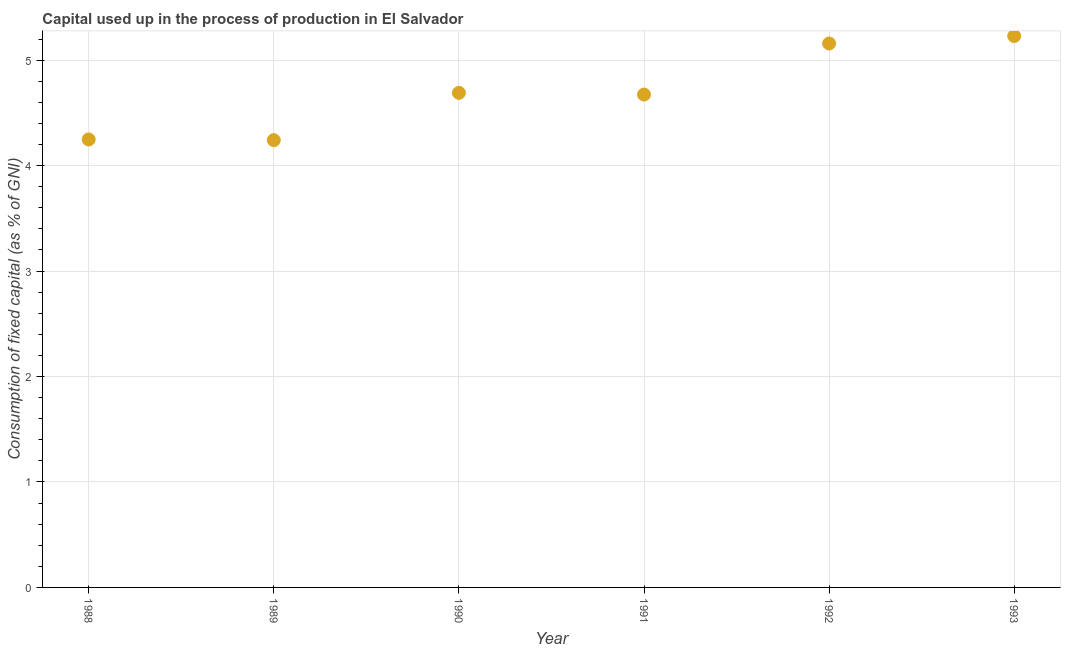What is the consumption of fixed capital in 1993?
Give a very brief answer. 5.23. Across all years, what is the maximum consumption of fixed capital?
Make the answer very short. 5.23. Across all years, what is the minimum consumption of fixed capital?
Your response must be concise. 4.24. In which year was the consumption of fixed capital minimum?
Give a very brief answer. 1989. What is the sum of the consumption of fixed capital?
Your answer should be compact. 28.24. What is the difference between the consumption of fixed capital in 1990 and 1992?
Offer a terse response. -0.47. What is the average consumption of fixed capital per year?
Make the answer very short. 4.71. What is the median consumption of fixed capital?
Provide a short and direct response. 4.68. In how many years, is the consumption of fixed capital greater than 2.4 %?
Keep it short and to the point. 6. Do a majority of the years between 1992 and 1991 (inclusive) have consumption of fixed capital greater than 2.8 %?
Offer a very short reply. No. What is the ratio of the consumption of fixed capital in 1991 to that in 1992?
Ensure brevity in your answer.  0.91. Is the difference between the consumption of fixed capital in 1989 and 1992 greater than the difference between any two years?
Keep it short and to the point. No. What is the difference between the highest and the second highest consumption of fixed capital?
Offer a very short reply. 0.07. Is the sum of the consumption of fixed capital in 1990 and 1991 greater than the maximum consumption of fixed capital across all years?
Your answer should be compact. Yes. What is the difference between the highest and the lowest consumption of fixed capital?
Offer a very short reply. 0.99. In how many years, is the consumption of fixed capital greater than the average consumption of fixed capital taken over all years?
Provide a short and direct response. 2. Does the consumption of fixed capital monotonically increase over the years?
Give a very brief answer. No. How many dotlines are there?
Provide a short and direct response. 1. Are the values on the major ticks of Y-axis written in scientific E-notation?
Your answer should be very brief. No. What is the title of the graph?
Ensure brevity in your answer.  Capital used up in the process of production in El Salvador. What is the label or title of the Y-axis?
Make the answer very short. Consumption of fixed capital (as % of GNI). What is the Consumption of fixed capital (as % of GNI) in 1988?
Give a very brief answer. 4.25. What is the Consumption of fixed capital (as % of GNI) in 1989?
Your answer should be compact. 4.24. What is the Consumption of fixed capital (as % of GNI) in 1990?
Offer a very short reply. 4.69. What is the Consumption of fixed capital (as % of GNI) in 1991?
Make the answer very short. 4.67. What is the Consumption of fixed capital (as % of GNI) in 1992?
Keep it short and to the point. 5.16. What is the Consumption of fixed capital (as % of GNI) in 1993?
Keep it short and to the point. 5.23. What is the difference between the Consumption of fixed capital (as % of GNI) in 1988 and 1989?
Offer a very short reply. 0.01. What is the difference between the Consumption of fixed capital (as % of GNI) in 1988 and 1990?
Provide a succinct answer. -0.44. What is the difference between the Consumption of fixed capital (as % of GNI) in 1988 and 1991?
Ensure brevity in your answer.  -0.43. What is the difference between the Consumption of fixed capital (as % of GNI) in 1988 and 1992?
Give a very brief answer. -0.91. What is the difference between the Consumption of fixed capital (as % of GNI) in 1988 and 1993?
Ensure brevity in your answer.  -0.98. What is the difference between the Consumption of fixed capital (as % of GNI) in 1989 and 1990?
Keep it short and to the point. -0.45. What is the difference between the Consumption of fixed capital (as % of GNI) in 1989 and 1991?
Keep it short and to the point. -0.43. What is the difference between the Consumption of fixed capital (as % of GNI) in 1989 and 1992?
Offer a terse response. -0.92. What is the difference between the Consumption of fixed capital (as % of GNI) in 1989 and 1993?
Offer a very short reply. -0.99. What is the difference between the Consumption of fixed capital (as % of GNI) in 1990 and 1991?
Offer a very short reply. 0.02. What is the difference between the Consumption of fixed capital (as % of GNI) in 1990 and 1992?
Give a very brief answer. -0.47. What is the difference between the Consumption of fixed capital (as % of GNI) in 1990 and 1993?
Provide a short and direct response. -0.54. What is the difference between the Consumption of fixed capital (as % of GNI) in 1991 and 1992?
Give a very brief answer. -0.48. What is the difference between the Consumption of fixed capital (as % of GNI) in 1991 and 1993?
Keep it short and to the point. -0.56. What is the difference between the Consumption of fixed capital (as % of GNI) in 1992 and 1993?
Ensure brevity in your answer.  -0.07. What is the ratio of the Consumption of fixed capital (as % of GNI) in 1988 to that in 1990?
Provide a short and direct response. 0.91. What is the ratio of the Consumption of fixed capital (as % of GNI) in 1988 to that in 1991?
Give a very brief answer. 0.91. What is the ratio of the Consumption of fixed capital (as % of GNI) in 1988 to that in 1992?
Provide a succinct answer. 0.82. What is the ratio of the Consumption of fixed capital (as % of GNI) in 1988 to that in 1993?
Make the answer very short. 0.81. What is the ratio of the Consumption of fixed capital (as % of GNI) in 1989 to that in 1990?
Your answer should be compact. 0.9. What is the ratio of the Consumption of fixed capital (as % of GNI) in 1989 to that in 1991?
Give a very brief answer. 0.91. What is the ratio of the Consumption of fixed capital (as % of GNI) in 1989 to that in 1992?
Offer a very short reply. 0.82. What is the ratio of the Consumption of fixed capital (as % of GNI) in 1989 to that in 1993?
Ensure brevity in your answer.  0.81. What is the ratio of the Consumption of fixed capital (as % of GNI) in 1990 to that in 1991?
Ensure brevity in your answer.  1. What is the ratio of the Consumption of fixed capital (as % of GNI) in 1990 to that in 1992?
Your answer should be compact. 0.91. What is the ratio of the Consumption of fixed capital (as % of GNI) in 1990 to that in 1993?
Your answer should be very brief. 0.9. What is the ratio of the Consumption of fixed capital (as % of GNI) in 1991 to that in 1992?
Your answer should be very brief. 0.91. What is the ratio of the Consumption of fixed capital (as % of GNI) in 1991 to that in 1993?
Your answer should be compact. 0.89. 